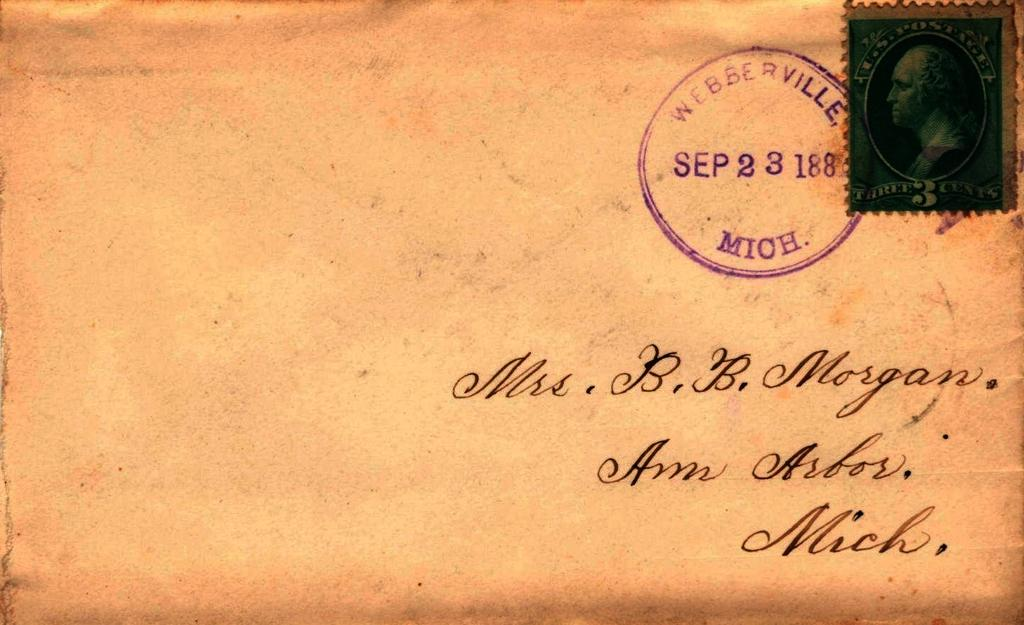<image>
Present a compact description of the photo's key features. An old envelope with a Webberville Michigan post office stamp on it. 